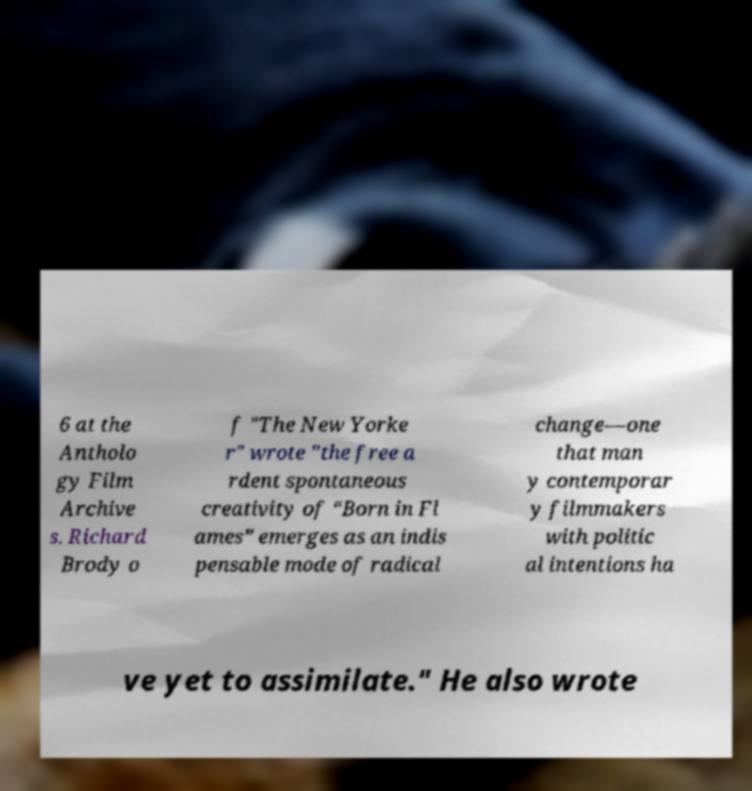Could you assist in decoding the text presented in this image and type it out clearly? 6 at the Antholo gy Film Archive s. Richard Brody o f "The New Yorke r" wrote "the free a rdent spontaneous creativity of “Born in Fl ames” emerges as an indis pensable mode of radical change—one that man y contemporar y filmmakers with politic al intentions ha ve yet to assimilate." He also wrote 